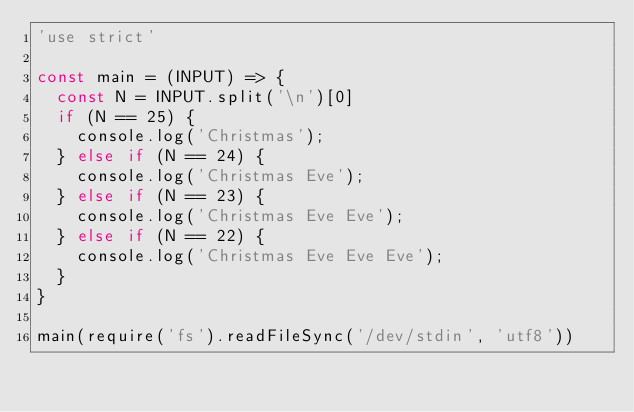Convert code to text. <code><loc_0><loc_0><loc_500><loc_500><_JavaScript_>'use strict'

const main = (INPUT) => {
  const N = INPUT.split('\n')[0]
  if (N == 25) {
    console.log('Christmas');
  } else if (N == 24) {
    console.log('Christmas Eve');
  } else if (N == 23) {
    console.log('Christmas Eve Eve');
  } else if (N == 22) {
    console.log('Christmas Eve Eve Eve');
  }
}

main(require('fs').readFileSync('/dev/stdin', 'utf8'))
</code> 